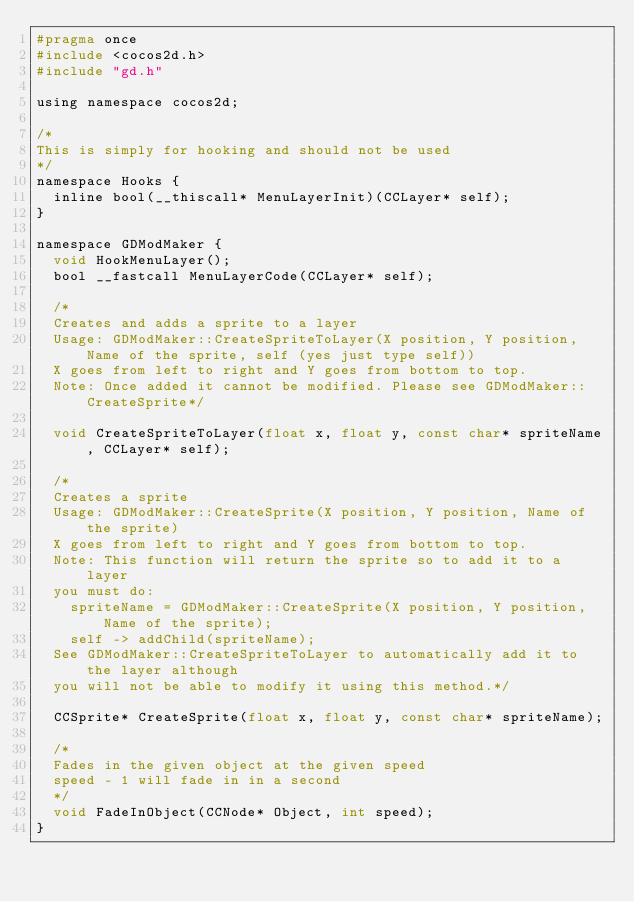Convert code to text. <code><loc_0><loc_0><loc_500><loc_500><_C_>#pragma once
#include <cocos2d.h>
#include "gd.h"

using namespace cocos2d;

/*
This is simply for hooking and should not be used
*/
namespace Hooks {
	inline bool(__thiscall* MenuLayerInit)(CCLayer* self);
}

namespace GDModMaker {
	void HookMenuLayer();
	bool __fastcall MenuLayerCode(CCLayer* self);

	/*
	Creates and adds a sprite to a layer
	Usage: GDModMaker::CreateSpriteToLayer(X position, Y position, Name of the sprite, self (yes just type self))
	X goes from left to right and Y goes from bottom to top.
	Note: Once added it cannot be modified. Please see GDModMaker::CreateSprite*/
	
	void CreateSpriteToLayer(float x, float y, const char* spriteName, CCLayer* self);

	/*
	Creates a sprite
	Usage: GDModMaker::CreateSprite(X position, Y position, Name of the sprite)
	X goes from left to right and Y goes from bottom to top.
	Note: This function will return the sprite so to add it to a layer
	you must do:
		spriteName = GDModMaker::CreateSprite(X position, Y position, Name of the sprite);
		self -> addChild(spriteName);
	See GDModMaker::CreateSpriteToLayer to automatically add it to the layer although
	you will not be able to modify it using this method.*/

	CCSprite* CreateSprite(float x, float y, const char* spriteName);

	/*
	Fades in the given object at the given speed
	speed - 1 will fade in in a second
	*/
	void FadeInObject(CCNode* Object, int speed);
}</code> 